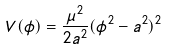<formula> <loc_0><loc_0><loc_500><loc_500>V ( \phi ) = \frac { \mu ^ { 2 } } { 2 a ^ { 2 } } ( \phi ^ { 2 } - a ^ { 2 } ) ^ { 2 }</formula> 